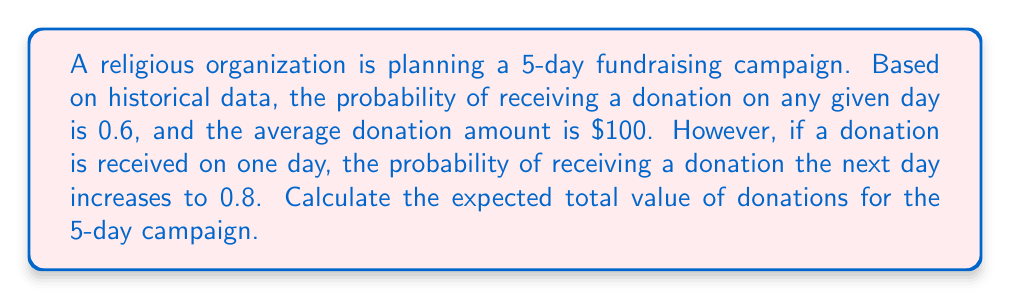Give your solution to this math problem. Let's approach this step-by-step:

1) First, we need to calculate the probability of receiving donations for each day:

   Day 1: $P(D_1) = 0.6$
   Day 2: $P(D_2) = P(D_1) \cdot 0.8 + (1-P(D_1)) \cdot 0.6 = 0.6 \cdot 0.8 + 0.4 \cdot 0.6 = 0.72$
   Day 3: $P(D_3) = P(D_2) \cdot 0.8 + (1-P(D_2)) \cdot 0.6 = 0.72 \cdot 0.8 + 0.28 \cdot 0.6 = 0.744$
   Day 4: $P(D_4) = P(D_3) \cdot 0.8 + (1-P(D_3)) \cdot 0.6 = 0.744 \cdot 0.8 + 0.256 \cdot 0.6 = 0.7488$
   Day 5: $P(D_5) = P(D_4) \cdot 0.8 + (1-P(D_4)) \cdot 0.6 = 0.7488 \cdot 0.8 + 0.2512 \cdot 0.6 = 0.74976$

2) Now, we can calculate the expected value of donations for each day:

   $E(D_1) = P(D_1) \cdot 100 = 0.6 \cdot 100 = 60$
   $E(D_2) = P(D_2) \cdot 100 = 0.72 \cdot 100 = 72$
   $E(D_3) = P(D_3) \cdot 100 = 0.744 \cdot 100 = 74.4$
   $E(D_4) = P(D_4) \cdot 100 = 0.7488 \cdot 100 = 74.88$
   $E(D_5) = P(D_5) \cdot 100 = 0.74976 \cdot 100 = 74.976$

3) The total expected value is the sum of the expected values for each day:

   $E(Total) = E(D_1) + E(D_2) + E(D_3) + E(D_4) + E(D_5)$
   $E(Total) = 60 + 72 + 74.4 + 74.88 + 74.976 = 356.256$

Therefore, the expected total value of donations for the 5-day campaign is $356.256.
Answer: $356.26 